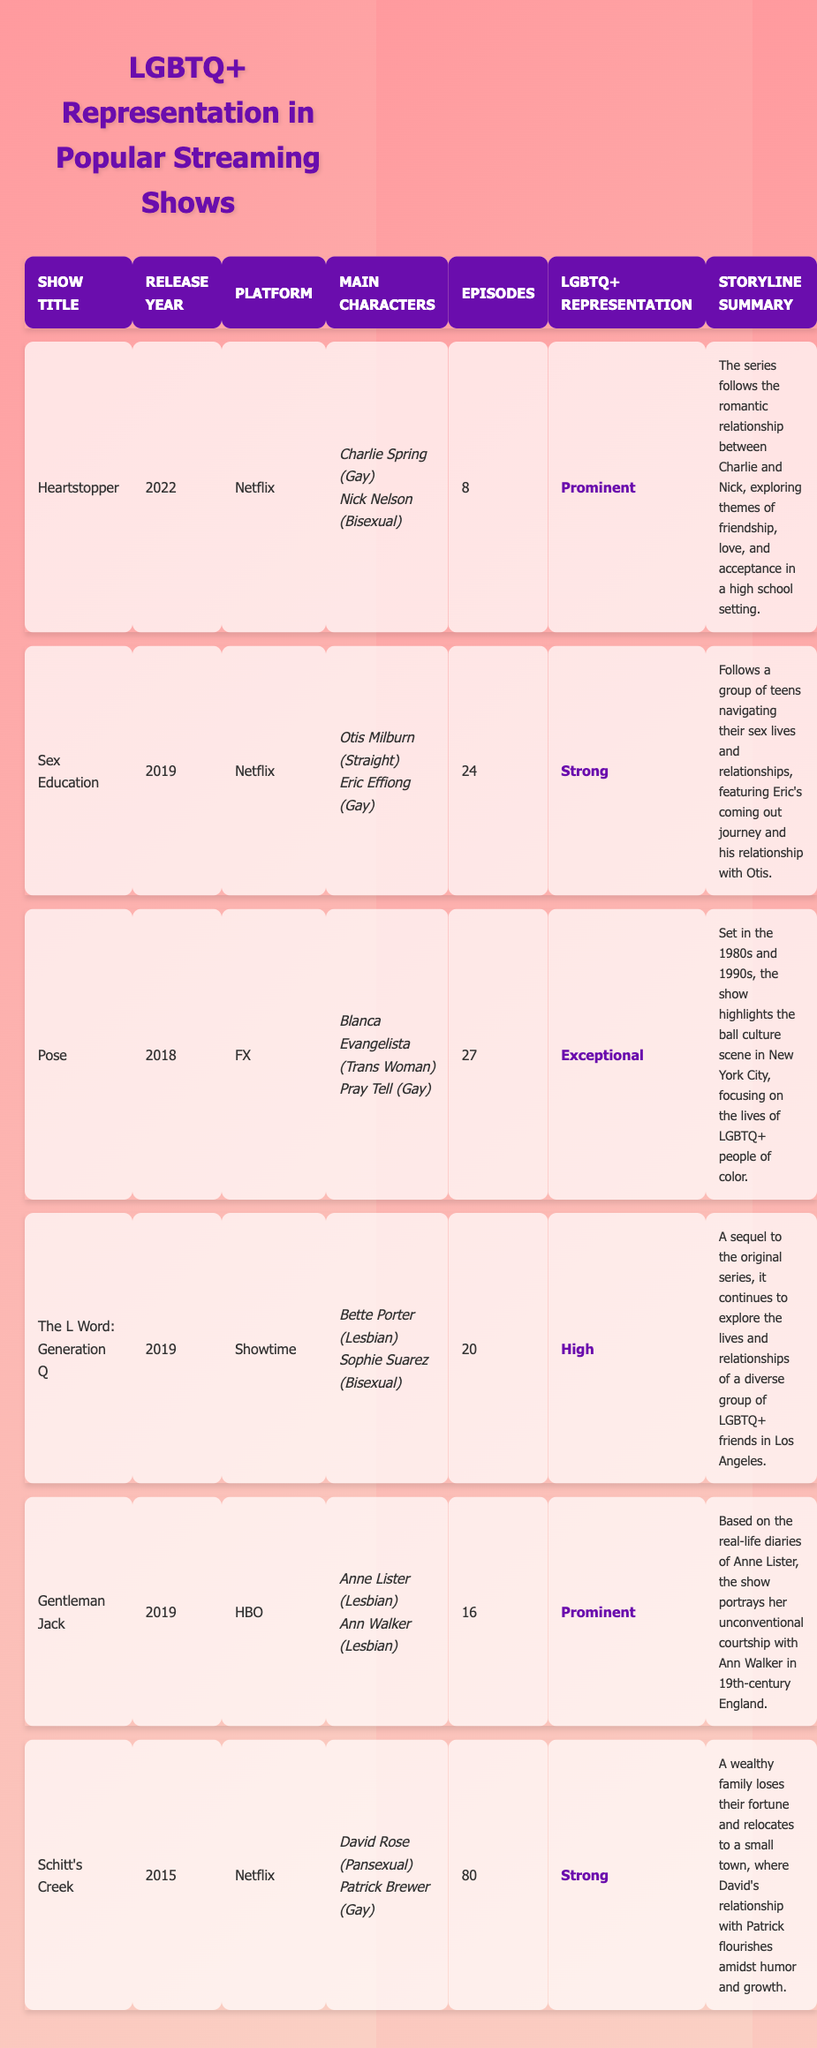What is the release year of "Sex Education"? According to the table, "Sex Education" has the release year listed in the corresponding column, which shows 2019.
Answer: 2019 Which platform has the most shows represented in the table? By reviewing the platforms in the table, Netflix appears three times (Heartstopper, Sex Education, Schitt's Creek), while others have fewer shows. Therefore, Netflix has the most representation.
Answer: Netflix How many total episodes are there across all shows? To find the total, we add the episode counts for all shows: 8 (Heartstopper) + 24 (Sex Education) + 27 (Pose) + 20 (The L Word: Generation Q) + 16 (Gentleman Jack) + 80 (Schitt's Creek) = 175.
Answer: 175 Is "Pose" the show with exceptional LGBTQ+ representation? Yes, the table indicates that "Pose" is labeled with "Exceptional" in the LGBTQ+ representation column.
Answer: Yes Which character from "Gentleman Jack" is a lesbian? The table shows that both main characters in "Gentleman Jack" (Anne Lister and Ann Walker) identify as lesbian.
Answer: Anne Lister and Ann Walker What is the average number of episodes for shows with strong LGBTQ+ representation? The shows with "Strong" representation are "Sex Education" (24 episodes), "Schitt's Creek" (80 episodes), and "Heartstopper" (8 episodes). We calculate the average: (24 + 80 + 8) / 3 = 37.33, rounding it gives an average of 37 episodes.
Answer: 37 How many shows have LGBTQ+ representation rated as "Strong" or higher? In the table, the shows with representation rated as "Strong" or higher are "Heartstopper", "Sex Education", "Pose", "The L Word: Generation Q", "Gentleman Jack", and "Schitt's Creek", totaling six shows.
Answer: 6 Which show has the highest episode count? From the table, "Schitt's Creek" has the highest number of episodes listed as 80, compared to the others.
Answer: Schitt's Creek Are there any shows that focus on LGBTQ+ individuals of color? Yes, the show "Pose" focuses on the lives of LGBTQ+ people of color as indicated in its storyline summary.
Answer: Yes 